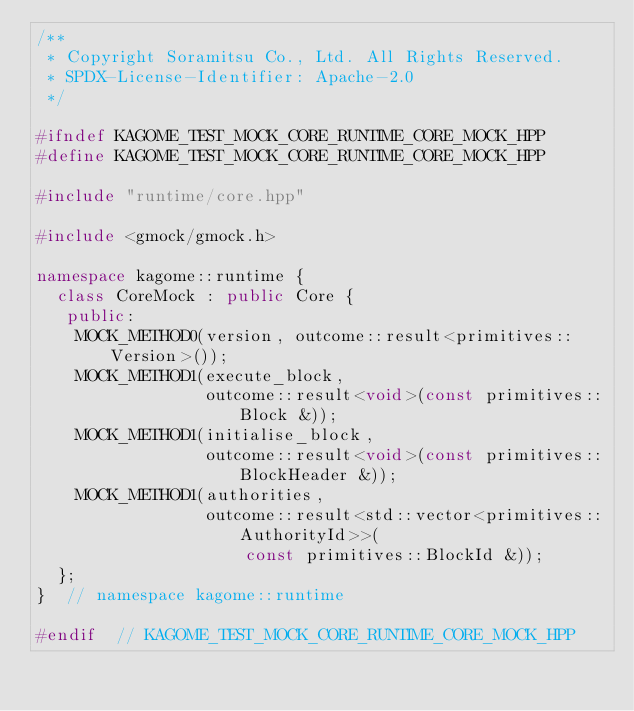<code> <loc_0><loc_0><loc_500><loc_500><_C++_>/**
 * Copyright Soramitsu Co., Ltd. All Rights Reserved.
 * SPDX-License-Identifier: Apache-2.0
 */

#ifndef KAGOME_TEST_MOCK_CORE_RUNTIME_CORE_MOCK_HPP
#define KAGOME_TEST_MOCK_CORE_RUNTIME_CORE_MOCK_HPP

#include "runtime/core.hpp"

#include <gmock/gmock.h>

namespace kagome::runtime {
  class CoreMock : public Core {
   public:
    MOCK_METHOD0(version, outcome::result<primitives::Version>());
    MOCK_METHOD1(execute_block,
                 outcome::result<void>(const primitives::Block &));
    MOCK_METHOD1(initialise_block,
                 outcome::result<void>(const primitives::BlockHeader &));
    MOCK_METHOD1(authorities,
                 outcome::result<std::vector<primitives::AuthorityId>>(
                     const primitives::BlockId &));
  };
}  // namespace kagome::runtime

#endif  // KAGOME_TEST_MOCK_CORE_RUNTIME_CORE_MOCK_HPP
</code> 